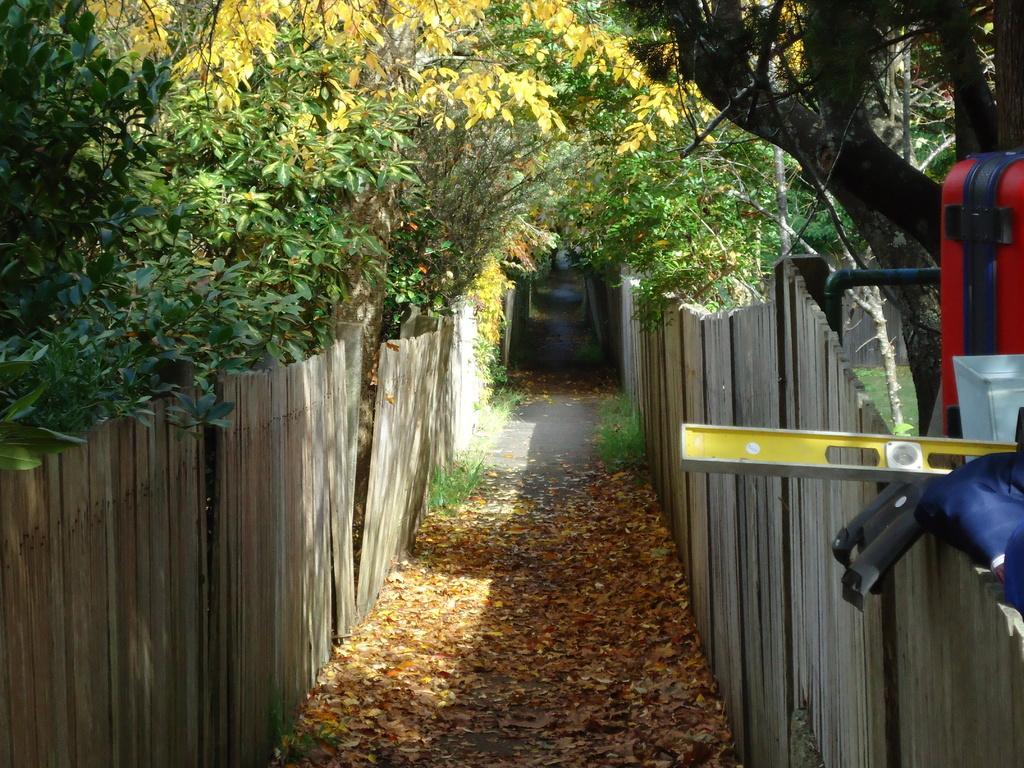Please provide a concise description of this image. In this image, we can see the ground. We can see the wooden fence. There are a few trees. We can see some grass and dried leaves. We can see some objects on the right. 